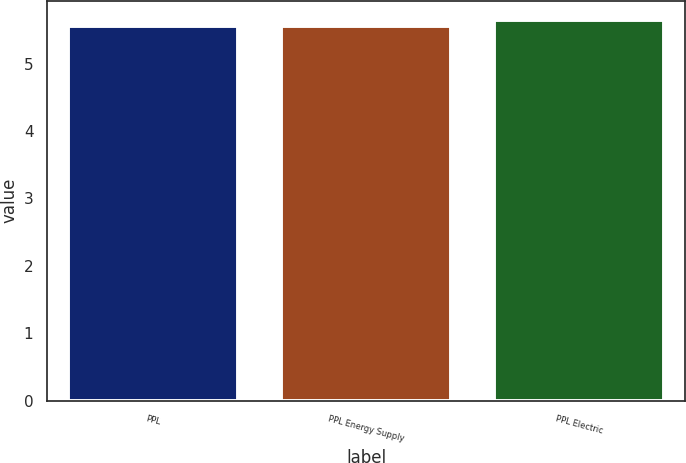<chart> <loc_0><loc_0><loc_500><loc_500><bar_chart><fcel>PPL<fcel>PPL Energy Supply<fcel>PPL Electric<nl><fcel>5.55<fcel>5.56<fcel>5.65<nl></chart> 